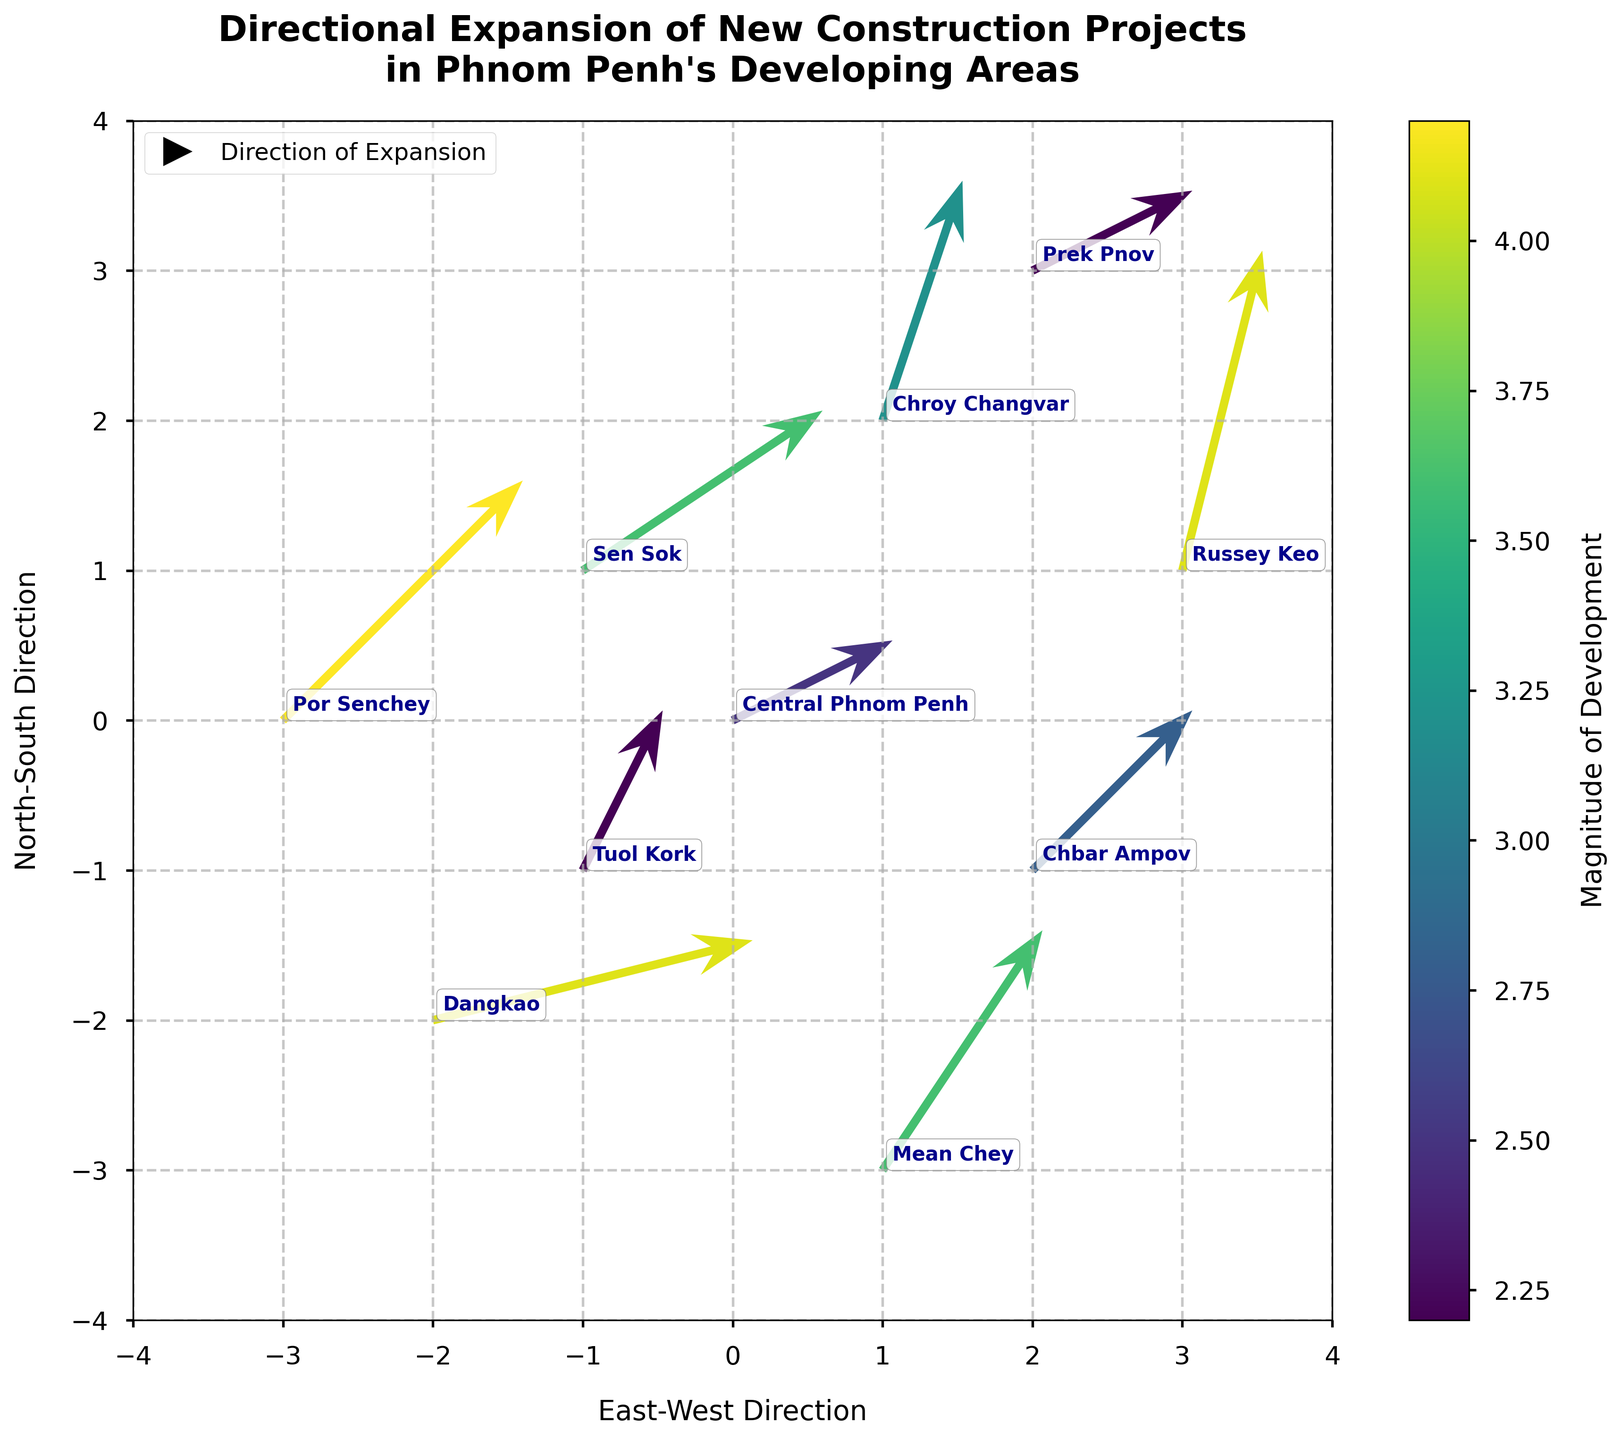What is the overall title of the figure? The title of the figure is prominently displayed at the top and provides a summary of the visualization's subject.
Answer: Directional Expansion of New Construction Projects in Phnom Penh's Developing Areas How many data points are shown in the plot? Counting the number of arrows in the plot gives the total number of data points.
Answer: 10 In which developing area is the highest magnitude of development observed? The color of the arrows indicates the magnitude of development, with the darkest color signifying the highest magnitude. Identifying the location with the darkest arrow will answer the question.
Answer: Por Senchey What direction is the construction expanding in Russey Keo? Observing the direction of the arrow labeled as Russey Keo indicates the direction of the construction expansion in that area.
Answer: Mainly north Which location shows the weakest development magnitude? The lightest-colored arrow indicates the weakest development magnitude. Identifying the corresponding location provides the answer.
Answer: Tuol Kork and Prek Pnov Are there any locations showing a directly northward expansion? Reviewing the arrows’ directions shows which ones are pointing straight up, indicating northward expansion.
Answer: None Which area has the steepest northward slope (largest vertical component)? Comparing the lengths of the vertical components (v values) of all arrows to find the largest vertical component.
Answer: Russey Keo What is the average magnitude of development across all locations? Summing up the magnitudes and dividing by the number of locations gives the average: (2.5+3.2+3.6+2.8+4.1+4.1+4.2+3.6+2.2+2.2) / 10 = 3.25
Answer: 3.25 Which two areas have the same magnitude of development, and what is that magnitude? Identifying any repeat values in the magnitude column and matching them to their respective locations in the plot.
Answer: Dangkao and Russey Keo, 4.1 Between Central Phnom Penh and Sen Sok, which area has a more eastward expansion? Examining the arrows’ horizontal components (u values) for both locations and comparing them to determine which is more eastward.
Answer: Sen Sok 